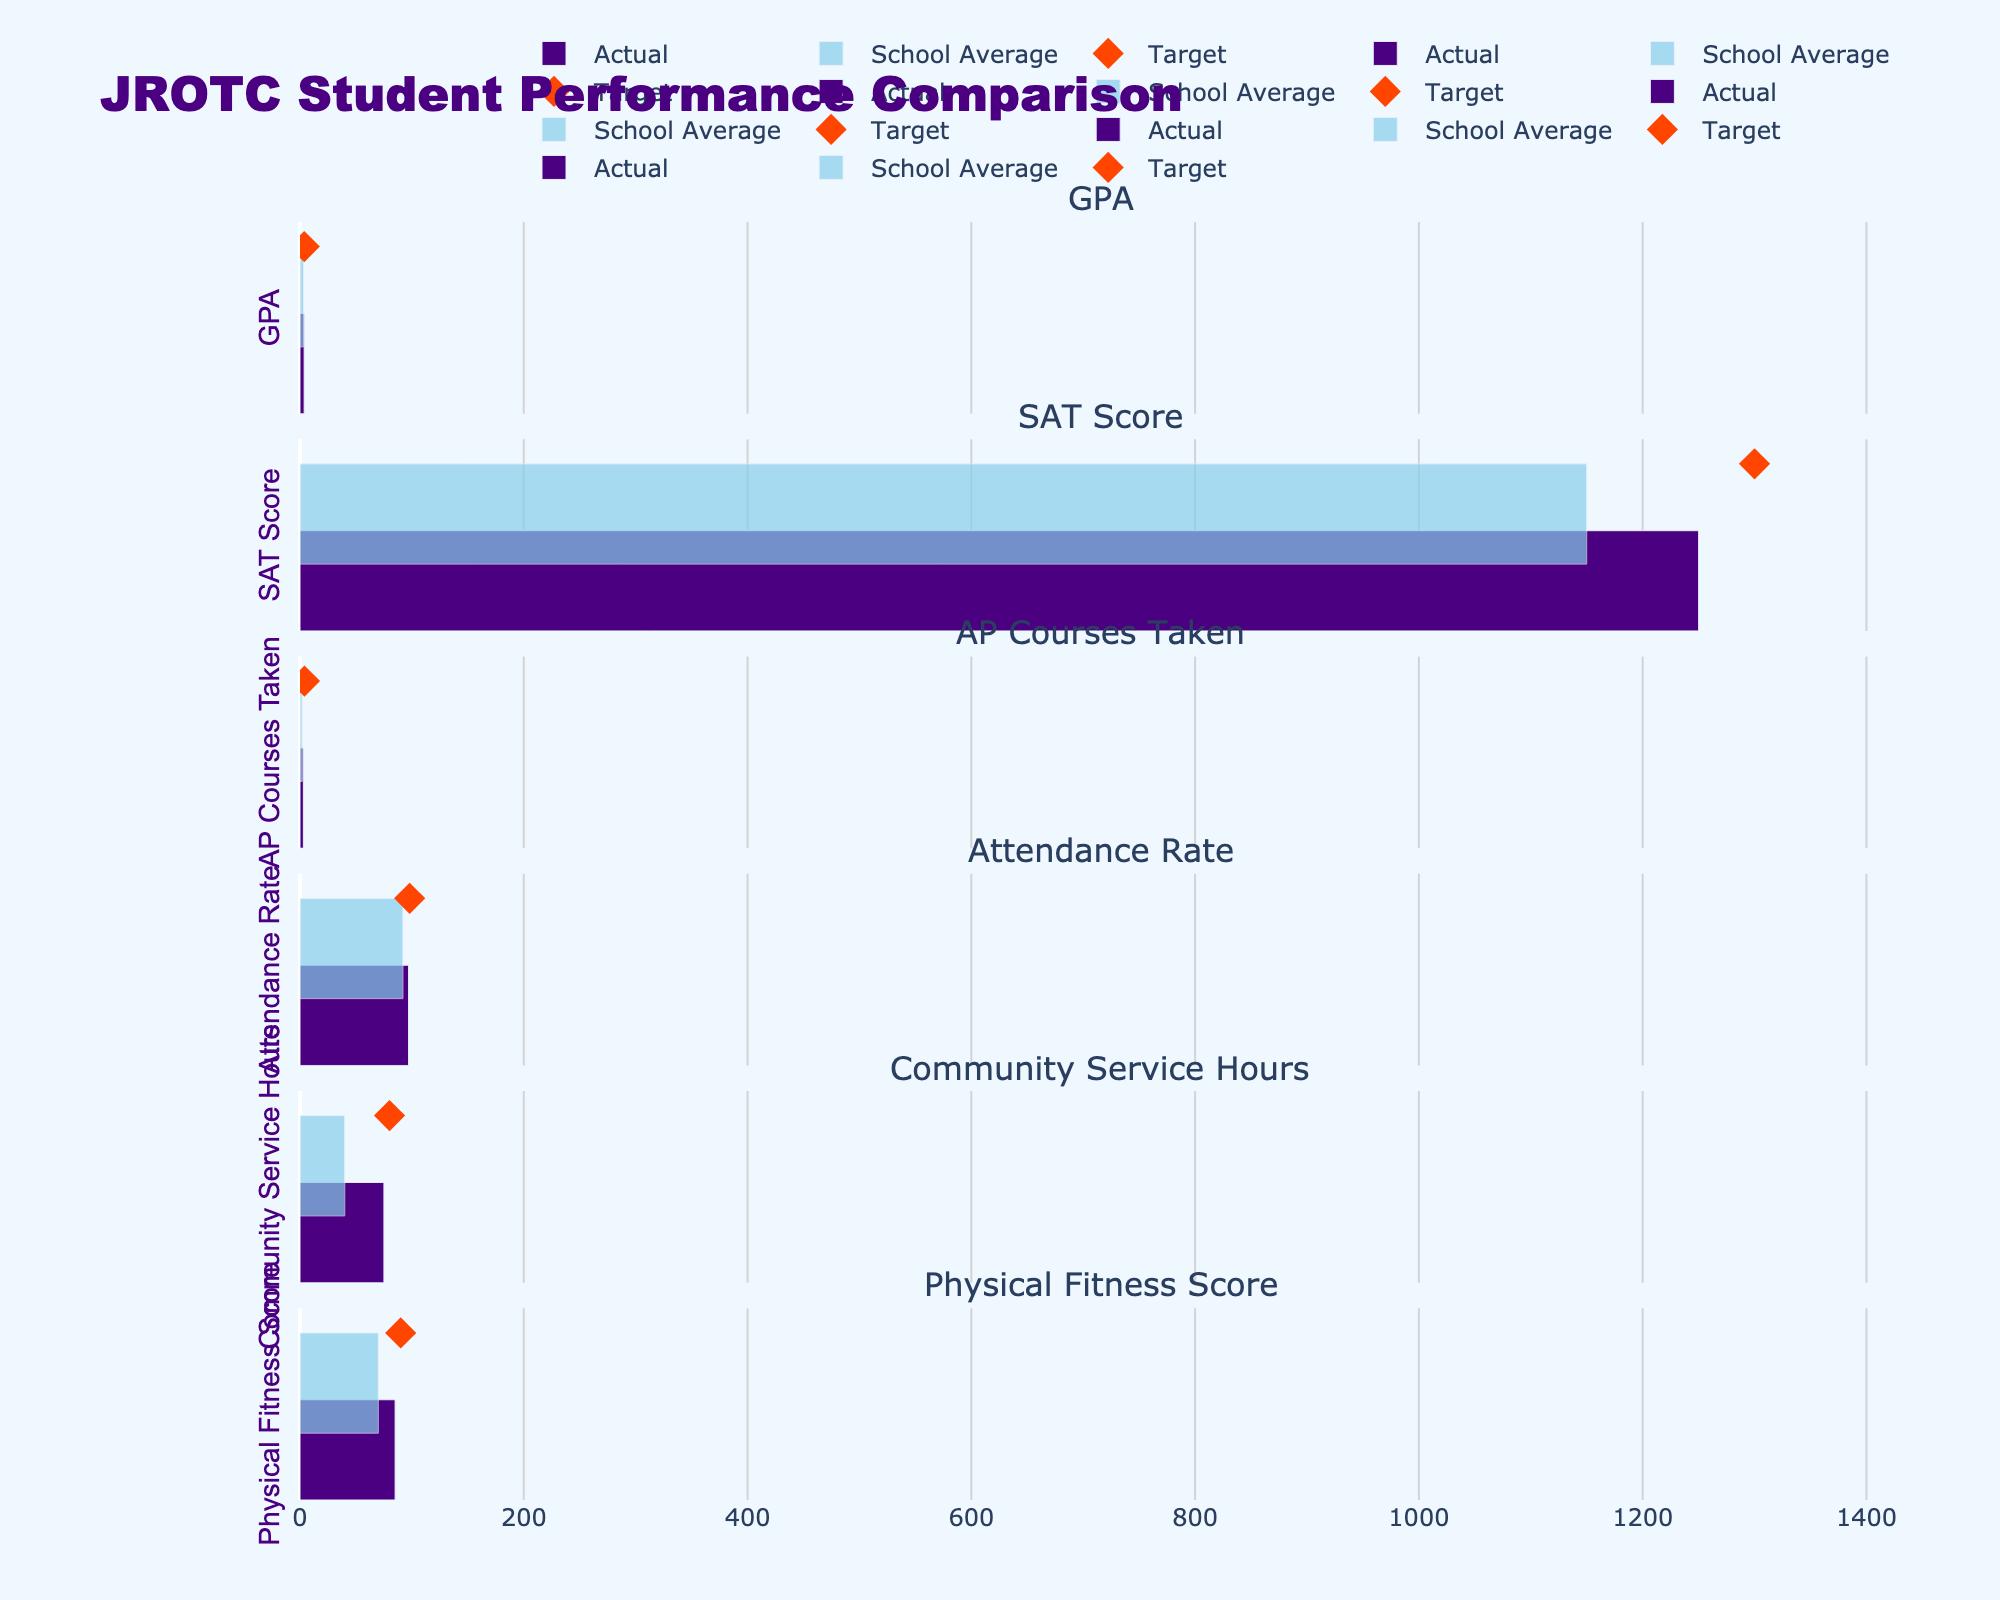What is the title of the figure? The title of the figure is found at the top of the visual representation. The exact title is "JROTC Student Performance Comparison."
Answer: JROTC Student Performance Comparison How many categories are compared in this figure? By counting the number of subplot titles or rows in the figure, we see that there are six categories being compared.
Answer: Six What is the highest GPA among Actual, Comparative, and Target values for the JROTC students? The Actual GPA value for the JROTC students is 3.7, the Comparative (school average) is 3.2, and the Target is 3.8. The highest among these is the Target value of 3.8.
Answer: 3.8 In which category is the difference between the actual and target values the smallest? To find this, we calculate the difference between the actual and target values for each category: GPA (3.8 - 3.7 = 0.1), SAT Score (1300 - 1250 = 50), AP Courses Taken (4 - 3 = 1), Attendance Rate (98 - 97 = 1), Community Service Hours (80 - 75 = 5), and Physical Fitness Score (90 - 85 = 5). The smallest difference is 0.1 for the GPA category.
Answer: GPA Which category has the largest gap between the JROTC students' actual values and the school averages? Calculating the absolute differences for each category: GPA (3.7 - 3.2 = 0.5), SAT Score (1250 - 1150 = 100), AP Courses Taken (3 - 2 = 1), Attendance Rate (97 - 92 = 5), Community Service Hours (75 - 40 = 35), and Physical Fitness Score (85 - 70 = 15). The SAT Score category has the largest gap of 100 points.
Answer: SAT Score Are the JROTC students meeting their targets in any category? Comparing the actual values to the target values, we have: GPA (3.7 vs. 3.8), SAT Score (1250 vs. 1300), AP Courses Taken (3 vs. 4), Attendance Rate (97 vs. 98), Community Service Hours (75 vs. 80), and Physical Fitness Score (85 vs. 90). JROTC students are not meeting their targets in any category.
Answer: No In which categories do JROTC students outperform the school-wide averages? Comparing the JROTC students' actual values to the school-wide averages: GPA (3.7 vs. 3.2), SAT Score (1250 vs. 1150), AP Courses Taken (3 vs. 2), Attendance Rate (97 vs. 92), Community Service Hours (75 vs. 40), and Physical Fitness Score (85 vs. 70). JROTC students outperform the school-wide averages in all six categories.
Answer: All categories 